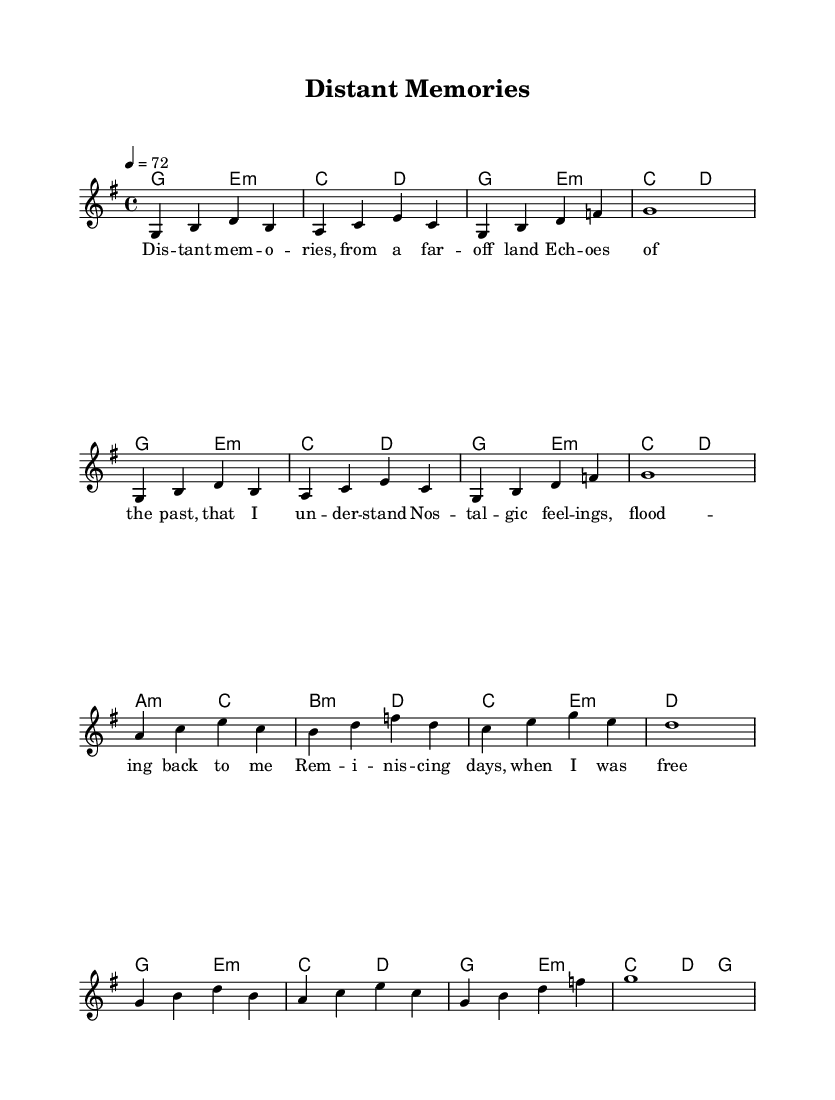What is the key signature of this music? The key signature is G major, indicated by one sharp (F#) on the staff.
Answer: G major What is the time signature of this music? The time signature is 4/4, which means there are four beats in each measure, and the quarter note gets one beat.
Answer: 4/4 What is the tempo marking of the piece? The tempo marking states that the tempo is set at 72 beats per minute, indicating a moderate pace.
Answer: 72 How many measures are in the melody section? By counting the measures in the melody line, there are eight measures present in the score.
Answer: Eight In what type of mode does the piece primarily compose its harmonies? The chord progression is primarily in a modal context, using both major and minor chords, suggesting a reflective tone typical of nostalgic ballads.
Answer: Minor mode What is the lyrical theme of the song? The lyrics reflect themes of nostalgia and remembrance, capturing emotional experiences from the past.
Answer: Nostalgia What is the highest pitch note in the melody? The highest pitch note in the melody is the note D, which is indicated in the third and sixth measures.
Answer: D 